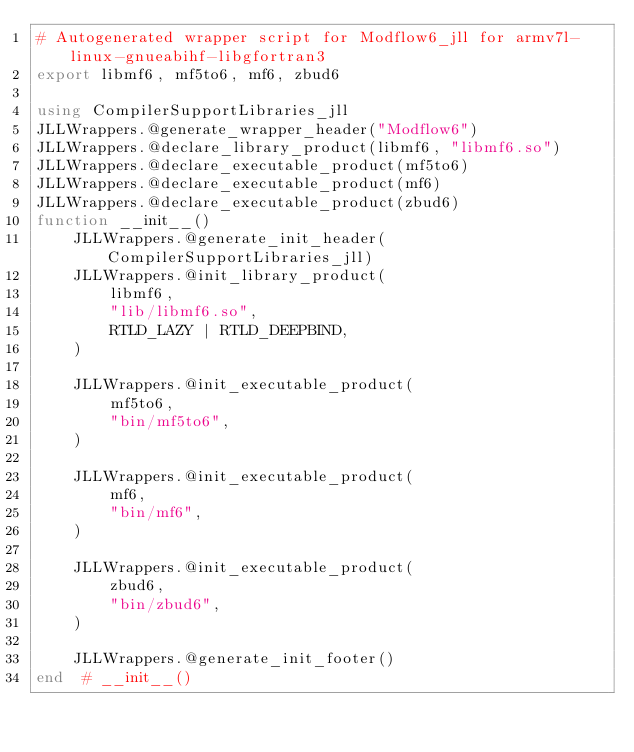Convert code to text. <code><loc_0><loc_0><loc_500><loc_500><_Julia_># Autogenerated wrapper script for Modflow6_jll for armv7l-linux-gnueabihf-libgfortran3
export libmf6, mf5to6, mf6, zbud6

using CompilerSupportLibraries_jll
JLLWrappers.@generate_wrapper_header("Modflow6")
JLLWrappers.@declare_library_product(libmf6, "libmf6.so")
JLLWrappers.@declare_executable_product(mf5to6)
JLLWrappers.@declare_executable_product(mf6)
JLLWrappers.@declare_executable_product(zbud6)
function __init__()
    JLLWrappers.@generate_init_header(CompilerSupportLibraries_jll)
    JLLWrappers.@init_library_product(
        libmf6,
        "lib/libmf6.so",
        RTLD_LAZY | RTLD_DEEPBIND,
    )

    JLLWrappers.@init_executable_product(
        mf5to6,
        "bin/mf5to6",
    )

    JLLWrappers.@init_executable_product(
        mf6,
        "bin/mf6",
    )

    JLLWrappers.@init_executable_product(
        zbud6,
        "bin/zbud6",
    )

    JLLWrappers.@generate_init_footer()
end  # __init__()
</code> 